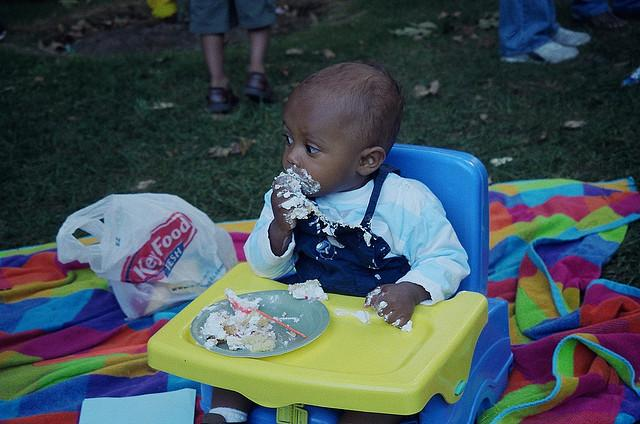Why is this person so messy?

Choices:
A) is misbehaving
B) bad manners
C) baby
D) is blind baby 